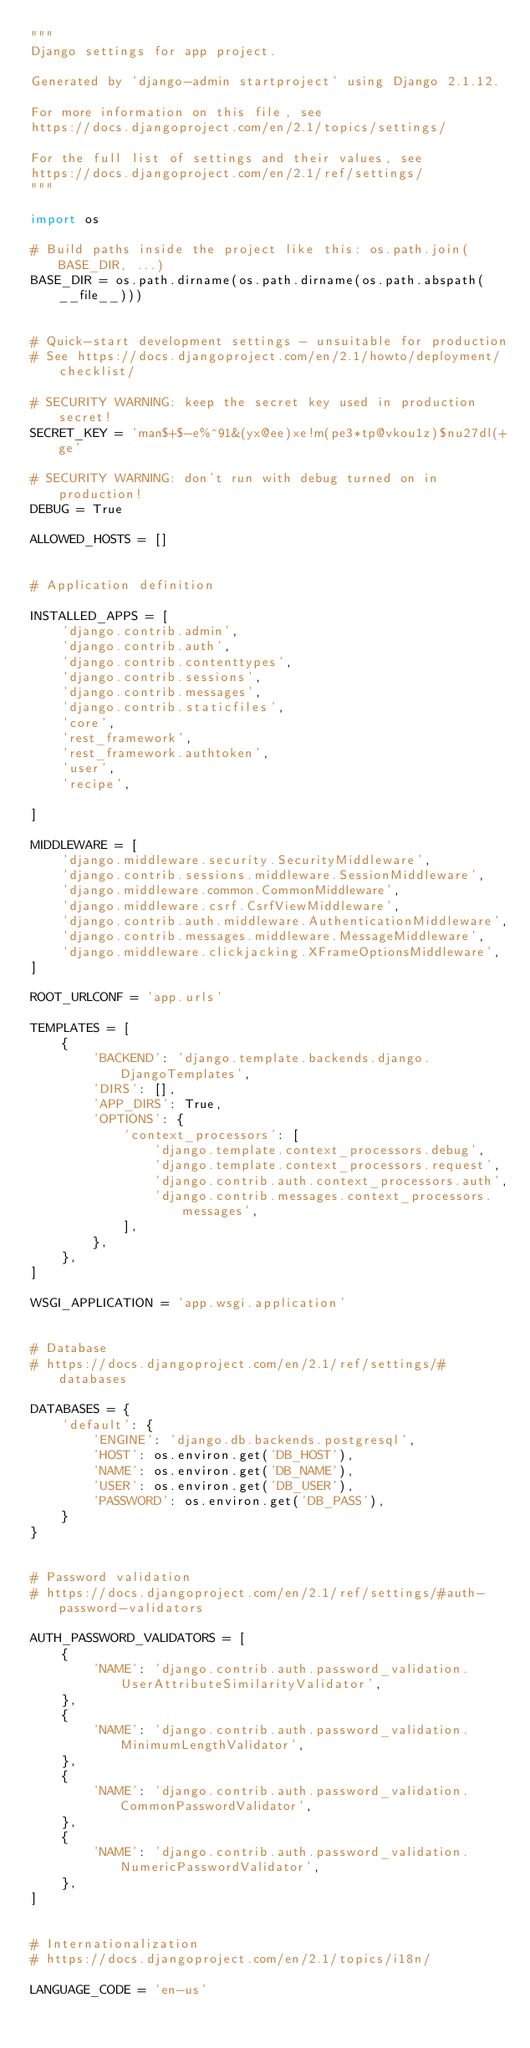Convert code to text. <code><loc_0><loc_0><loc_500><loc_500><_Python_>"""
Django settings for app project.

Generated by 'django-admin startproject' using Django 2.1.12.

For more information on this file, see
https://docs.djangoproject.com/en/2.1/topics/settings/

For the full list of settings and their values, see
https://docs.djangoproject.com/en/2.1/ref/settings/
"""

import os

# Build paths inside the project like this: os.path.join(BASE_DIR, ...)
BASE_DIR = os.path.dirname(os.path.dirname(os.path.abspath(__file__)))


# Quick-start development settings - unsuitable for production
# See https://docs.djangoproject.com/en/2.1/howto/deployment/checklist/

# SECURITY WARNING: keep the secret key used in production secret!
SECRET_KEY = 'man$+$-e%^91&(yx@ee)xe!m(pe3*tp@vkou1z)$nu27dl(+ge'

# SECURITY WARNING: don't run with debug turned on in production!
DEBUG = True

ALLOWED_HOSTS = []


# Application definition

INSTALLED_APPS = [
    'django.contrib.admin',
    'django.contrib.auth',
    'django.contrib.contenttypes',
    'django.contrib.sessions',
    'django.contrib.messages',
    'django.contrib.staticfiles',
    'core',
    'rest_framework',
    'rest_framework.authtoken',
    'user',
    'recipe',

]

MIDDLEWARE = [
    'django.middleware.security.SecurityMiddleware',
    'django.contrib.sessions.middleware.SessionMiddleware',
    'django.middleware.common.CommonMiddleware',
    'django.middleware.csrf.CsrfViewMiddleware',
    'django.contrib.auth.middleware.AuthenticationMiddleware',
    'django.contrib.messages.middleware.MessageMiddleware',
    'django.middleware.clickjacking.XFrameOptionsMiddleware',
]

ROOT_URLCONF = 'app.urls'

TEMPLATES = [
    {
        'BACKEND': 'django.template.backends.django.DjangoTemplates',
        'DIRS': [],
        'APP_DIRS': True,
        'OPTIONS': {
            'context_processors': [
                'django.template.context_processors.debug',
                'django.template.context_processors.request',
                'django.contrib.auth.context_processors.auth',
                'django.contrib.messages.context_processors.messages',
            ],
        },
    },
]

WSGI_APPLICATION = 'app.wsgi.application'


# Database
# https://docs.djangoproject.com/en/2.1/ref/settings/#databases

DATABASES = {
    'default': {
        'ENGINE': 'django.db.backends.postgresql',
        'HOST': os.environ.get('DB_HOST'),
        'NAME': os.environ.get('DB_NAME'),
        'USER': os.environ.get('DB_USER'),
        'PASSWORD': os.environ.get('DB_PASS'),
    }
}


# Password validation
# https://docs.djangoproject.com/en/2.1/ref/settings/#auth-password-validators

AUTH_PASSWORD_VALIDATORS = [
    {
        'NAME': 'django.contrib.auth.password_validation.UserAttributeSimilarityValidator',
    },
    {
        'NAME': 'django.contrib.auth.password_validation.MinimumLengthValidator',
    },
    {
        'NAME': 'django.contrib.auth.password_validation.CommonPasswordValidator',
    },
    {
        'NAME': 'django.contrib.auth.password_validation.NumericPasswordValidator',
    },
]


# Internationalization
# https://docs.djangoproject.com/en/2.1/topics/i18n/

LANGUAGE_CODE = 'en-us'
</code> 